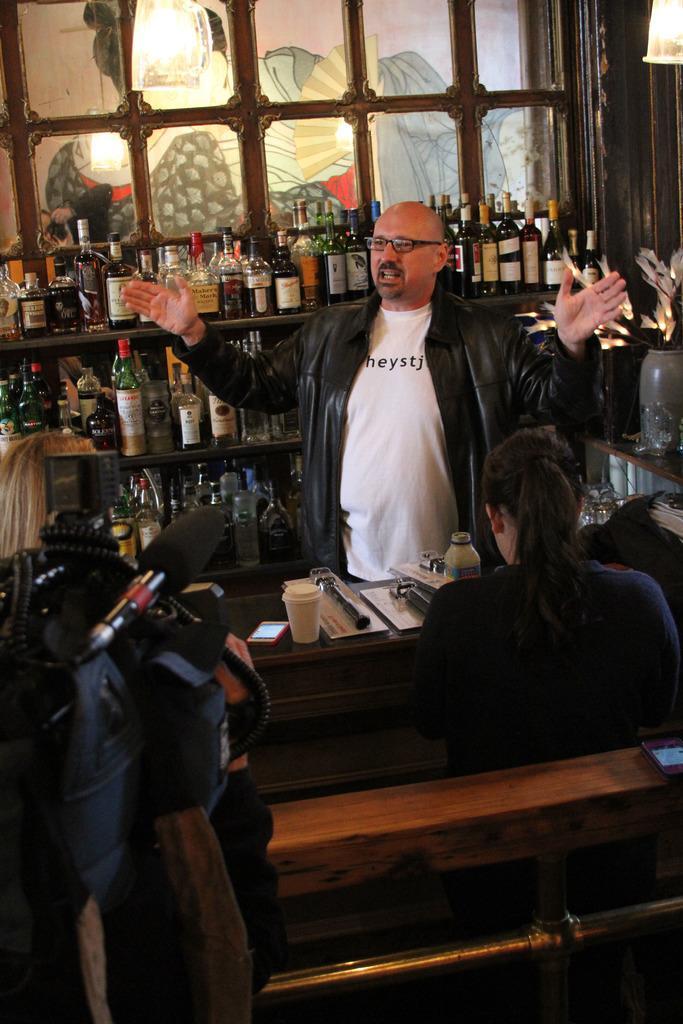Could you give a brief overview of what you see in this image? In this image there is a man wearing glasses and a jacket. Behind the man there is a rack with full of alcohol bottles and behind the rack there is a window. In the right there is a flower vase. There is also a woman. Image also consists of a mobile phone, white cups, bottle and some objects on the wooden surface. In the left there is a mike and also some person. 